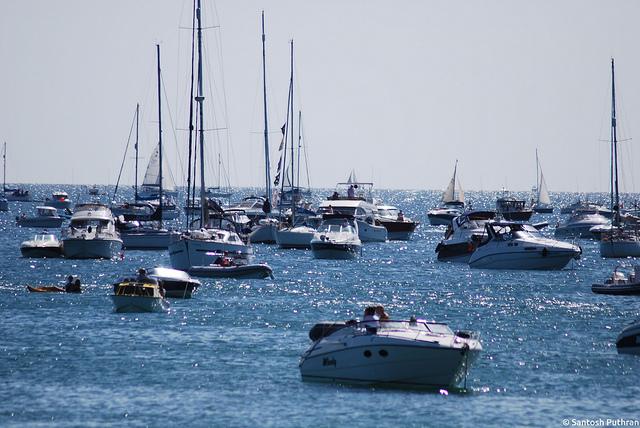How many boats are seen?
Short answer required. 27. What color are the boats?
Give a very brief answer. White. Do all the boats have sails?
Write a very short answer. No. 